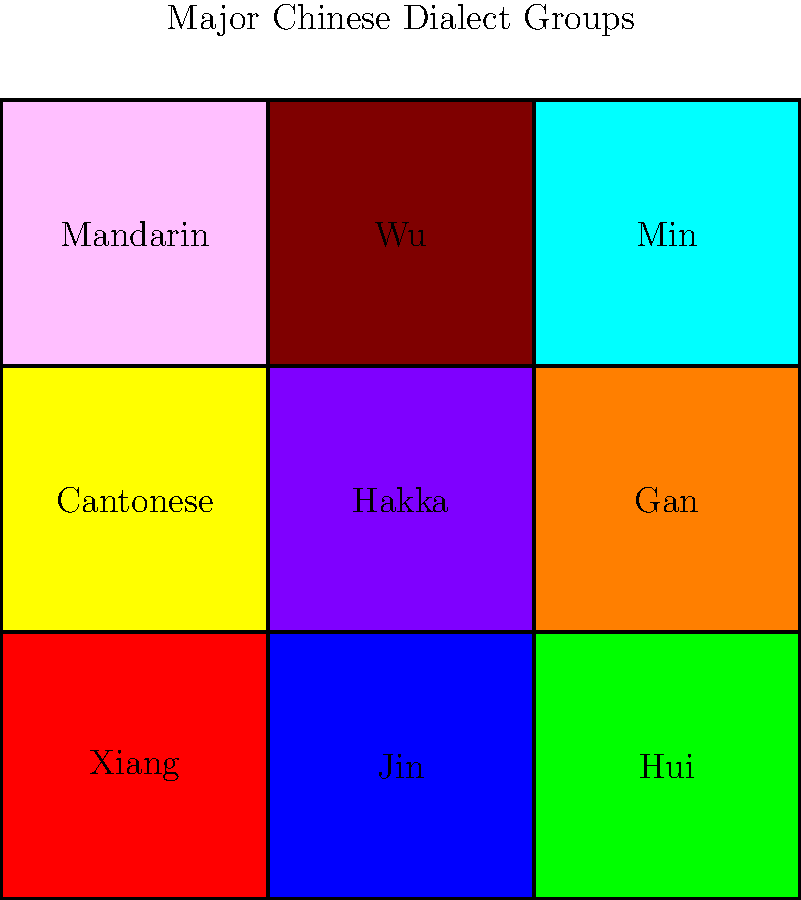Based on the color-coded map of major Chinese dialect groups, which dialect is represented by the yellow region in the center of the map? To answer this question, we need to analyze the color-coded map of major Chinese dialect groups:

1. The map is divided into 9 regions, each represented by a different color.
2. Each region is labeled with the name of a major Chinese dialect group.
3. The colors used in the map are: red, blue, green, yellow, purple, orange, pink, brown, and cyan.
4. The yellow region is located in the center of the map.
5. By examining the labels, we can see that the dialect group in the center of the map is labeled "Hakka".
6. The yellow region corresponds to the area labeled "Hakka".

Therefore, the dialect represented by the yellow region in the center of the map is Hakka.
Answer: Hakka 